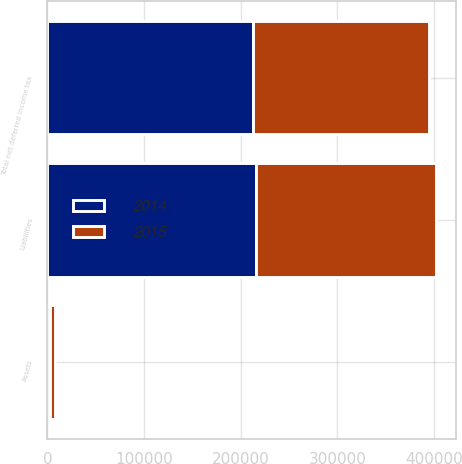Convert chart to OTSL. <chart><loc_0><loc_0><loc_500><loc_500><stacked_bar_chart><ecel><fcel>Assets<fcel>Liabilities<fcel>Total net deferred income tax<nl><fcel>2015<fcel>4657<fcel>186491<fcel>181834<nl><fcel>2014<fcel>3233<fcel>215981<fcel>212748<nl></chart> 